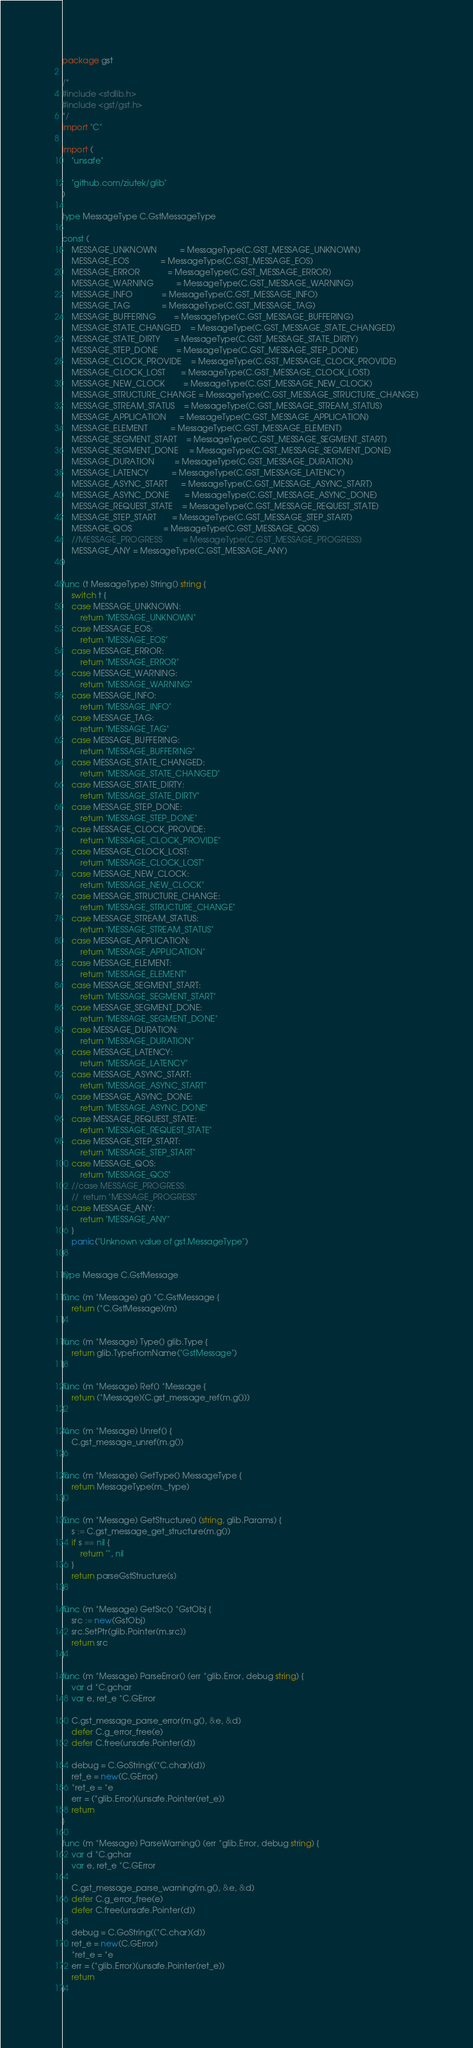<code> <loc_0><loc_0><loc_500><loc_500><_Go_>package gst

/*
#include <stdlib.h>
#include <gst/gst.h>
*/
import "C"

import (
	"unsafe"

	"github.com/ziutek/glib"
)

type MessageType C.GstMessageType

const (
	MESSAGE_UNKNOWN          = MessageType(C.GST_MESSAGE_UNKNOWN)
	MESSAGE_EOS              = MessageType(C.GST_MESSAGE_EOS)
	MESSAGE_ERROR            = MessageType(C.GST_MESSAGE_ERROR)
	MESSAGE_WARNING          = MessageType(C.GST_MESSAGE_WARNING)
	MESSAGE_INFO             = MessageType(C.GST_MESSAGE_INFO)
	MESSAGE_TAG              = MessageType(C.GST_MESSAGE_TAG)
	MESSAGE_BUFFERING        = MessageType(C.GST_MESSAGE_BUFFERING)
	MESSAGE_STATE_CHANGED    = MessageType(C.GST_MESSAGE_STATE_CHANGED)
	MESSAGE_STATE_DIRTY      = MessageType(C.GST_MESSAGE_STATE_DIRTY)
	MESSAGE_STEP_DONE        = MessageType(C.GST_MESSAGE_STEP_DONE)
	MESSAGE_CLOCK_PROVIDE    = MessageType(C.GST_MESSAGE_CLOCK_PROVIDE)
	MESSAGE_CLOCK_LOST       = MessageType(C.GST_MESSAGE_CLOCK_LOST)
	MESSAGE_NEW_CLOCK        = MessageType(C.GST_MESSAGE_NEW_CLOCK)
	MESSAGE_STRUCTURE_CHANGE = MessageType(C.GST_MESSAGE_STRUCTURE_CHANGE)
	MESSAGE_STREAM_STATUS    = MessageType(C.GST_MESSAGE_STREAM_STATUS)
	MESSAGE_APPLICATION      = MessageType(C.GST_MESSAGE_APPLICATION)
	MESSAGE_ELEMENT          = MessageType(C.GST_MESSAGE_ELEMENT)
	MESSAGE_SEGMENT_START    = MessageType(C.GST_MESSAGE_SEGMENT_START)
	MESSAGE_SEGMENT_DONE     = MessageType(C.GST_MESSAGE_SEGMENT_DONE)
	MESSAGE_DURATION         = MessageType(C.GST_MESSAGE_DURATION)
	MESSAGE_LATENCY          = MessageType(C.GST_MESSAGE_LATENCY)
	MESSAGE_ASYNC_START      = MessageType(C.GST_MESSAGE_ASYNC_START)
	MESSAGE_ASYNC_DONE       = MessageType(C.GST_MESSAGE_ASYNC_DONE)
	MESSAGE_REQUEST_STATE    = MessageType(C.GST_MESSAGE_REQUEST_STATE)
	MESSAGE_STEP_START       = MessageType(C.GST_MESSAGE_STEP_START)
	MESSAGE_QOS              = MessageType(C.GST_MESSAGE_QOS)
	//MESSAGE_PROGRESS         = MessageType(C.GST_MESSAGE_PROGRESS)
	MESSAGE_ANY = MessageType(C.GST_MESSAGE_ANY)
)

func (t MessageType) String() string {
	switch t {
	case MESSAGE_UNKNOWN:
		return "MESSAGE_UNKNOWN"
	case MESSAGE_EOS:
		return "MESSAGE_EOS"
	case MESSAGE_ERROR:
		return "MESSAGE_ERROR"
	case MESSAGE_WARNING:
		return "MESSAGE_WARNING"
	case MESSAGE_INFO:
		return "MESSAGE_INFO"
	case MESSAGE_TAG:
		return "MESSAGE_TAG"
	case MESSAGE_BUFFERING:
		return "MESSAGE_BUFFERING"
	case MESSAGE_STATE_CHANGED:
		return "MESSAGE_STATE_CHANGED"
	case MESSAGE_STATE_DIRTY:
		return "MESSAGE_STATE_DIRTY"
	case MESSAGE_STEP_DONE:
		return "MESSAGE_STEP_DONE"
	case MESSAGE_CLOCK_PROVIDE:
		return "MESSAGE_CLOCK_PROVIDE"
	case MESSAGE_CLOCK_LOST:
		return "MESSAGE_CLOCK_LOST"
	case MESSAGE_NEW_CLOCK:
		return "MESSAGE_NEW_CLOCK"
	case MESSAGE_STRUCTURE_CHANGE:
		return "MESSAGE_STRUCTURE_CHANGE"
	case MESSAGE_STREAM_STATUS:
		return "MESSAGE_STREAM_STATUS"
	case MESSAGE_APPLICATION:
		return "MESSAGE_APPLICATION"
	case MESSAGE_ELEMENT:
		return "MESSAGE_ELEMENT"
	case MESSAGE_SEGMENT_START:
		return "MESSAGE_SEGMENT_START"
	case MESSAGE_SEGMENT_DONE:
		return "MESSAGE_SEGMENT_DONE"
	case MESSAGE_DURATION:
		return "MESSAGE_DURATION"
	case MESSAGE_LATENCY:
		return "MESSAGE_LATENCY"
	case MESSAGE_ASYNC_START:
		return "MESSAGE_ASYNC_START"
	case MESSAGE_ASYNC_DONE:
		return "MESSAGE_ASYNC_DONE"
	case MESSAGE_REQUEST_STATE:
		return "MESSAGE_REQUEST_STATE"
	case MESSAGE_STEP_START:
		return "MESSAGE_STEP_START"
	case MESSAGE_QOS:
		return "MESSAGE_QOS"
	//case MESSAGE_PROGRESS:
	//	return "MESSAGE_PROGRESS"
	case MESSAGE_ANY:
		return "MESSAGE_ANY"
	}
	panic("Unknown value of gst.MessageType")
}

type Message C.GstMessage

func (m *Message) g() *C.GstMessage {
	return (*C.GstMessage)(m)
}

func (m *Message) Type() glib.Type {
	return glib.TypeFromName("GstMessage")
}

func (m *Message) Ref() *Message {
	return (*Message)(C.gst_message_ref(m.g()))
}

func (m *Message) Unref() {
	C.gst_message_unref(m.g())
}

func (m *Message) GetType() MessageType {
	return MessageType(m._type)
}

func (m *Message) GetStructure() (string, glib.Params) {
	s := C.gst_message_get_structure(m.g())
	if s == nil {
		return "", nil
	}
	return parseGstStructure(s)
}

func (m *Message) GetSrc() *GstObj {
	src := new(GstObj)
	src.SetPtr(glib.Pointer(m.src))
	return src
}

func (m *Message) ParseError() (err *glib.Error, debug string) {
	var d *C.gchar
	var e, ret_e *C.GError

	C.gst_message_parse_error(m.g(), &e, &d)
	defer C.g_error_free(e)
	defer C.free(unsafe.Pointer(d))

	debug = C.GoString((*C.char)(d))
	ret_e = new(C.GError)
	*ret_e = *e
	err = (*glib.Error)(unsafe.Pointer(ret_e))
	return
}

func (m *Message) ParseWarning() (err *glib.Error, debug string) {
	var d *C.gchar
	var e, ret_e *C.GError

	C.gst_message_parse_warning(m.g(), &e, &d)
	defer C.g_error_free(e)
	defer C.free(unsafe.Pointer(d))

	debug = C.GoString((*C.char)(d))
	ret_e = new(C.GError)
	*ret_e = *e
	err = (*glib.Error)(unsafe.Pointer(ret_e))
	return
}
</code> 